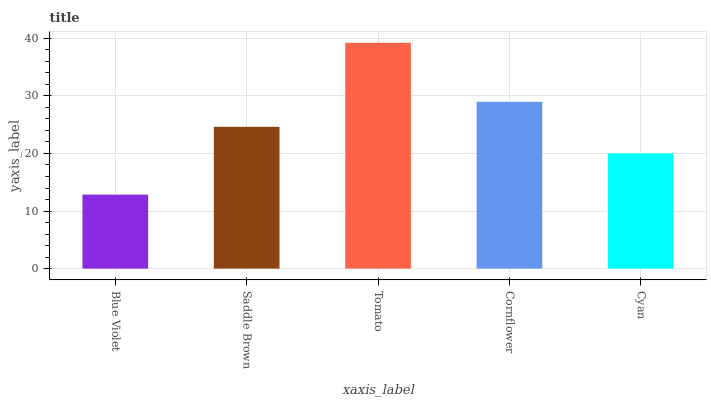Is Blue Violet the minimum?
Answer yes or no. Yes. Is Tomato the maximum?
Answer yes or no. Yes. Is Saddle Brown the minimum?
Answer yes or no. No. Is Saddle Brown the maximum?
Answer yes or no. No. Is Saddle Brown greater than Blue Violet?
Answer yes or no. Yes. Is Blue Violet less than Saddle Brown?
Answer yes or no. Yes. Is Blue Violet greater than Saddle Brown?
Answer yes or no. No. Is Saddle Brown less than Blue Violet?
Answer yes or no. No. Is Saddle Brown the high median?
Answer yes or no. Yes. Is Saddle Brown the low median?
Answer yes or no. Yes. Is Cornflower the high median?
Answer yes or no. No. Is Tomato the low median?
Answer yes or no. No. 